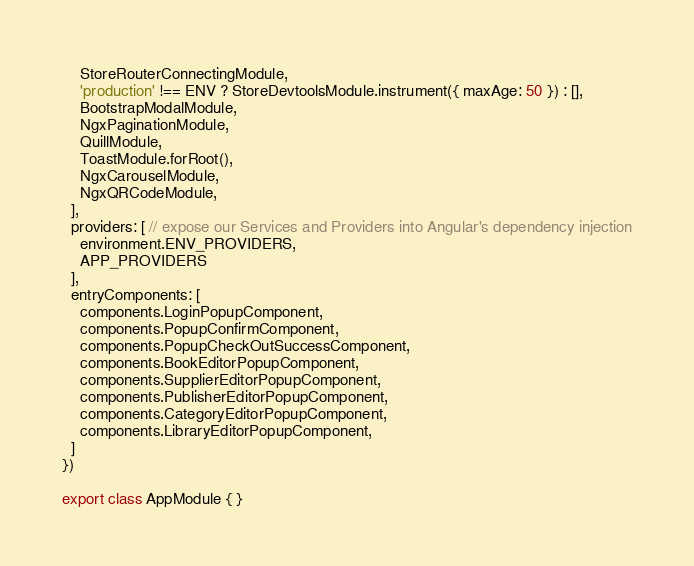<code> <loc_0><loc_0><loc_500><loc_500><_TypeScript_>    StoreRouterConnectingModule,
    'production' !== ENV ? StoreDevtoolsModule.instrument({ maxAge: 50 }) : [],
    BootstrapModalModule,
    NgxPaginationModule,
    QuillModule,
    ToastModule.forRoot(),
    NgxCarouselModule,
    NgxQRCodeModule,
  ],
  providers: [ // expose our Services and Providers into Angular's dependency injection
    environment.ENV_PROVIDERS,
    APP_PROVIDERS
  ],
  entryComponents: [
    components.LoginPopupComponent,
    components.PopupConfirmComponent,
    components.PopupCheckOutSuccessComponent,
    components.BookEditorPopupComponent,
    components.SupplierEditorPopupComponent,
    components.PublisherEditorPopupComponent,
    components.CategoryEditorPopupComponent,
    components.LibraryEditorPopupComponent,
  ]
})

export class AppModule { }
</code> 